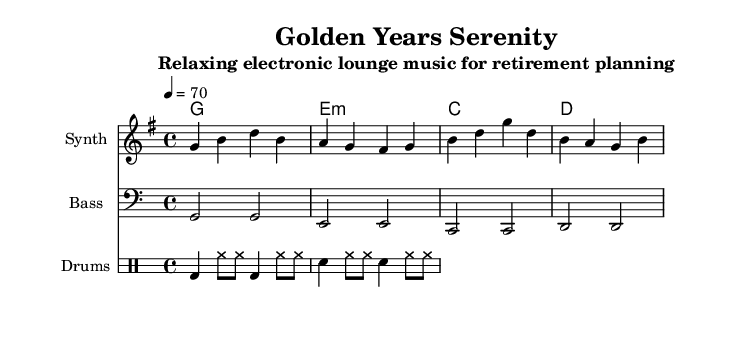What is the key signature of this music? The key signature is indicated at the beginning of the staff. This particular music is in the key of G major, which has one sharp (F#).
Answer: G major What is the time signature of this music? The time signature appears at the beginning of the score, showing that each measure consists of four beats, indicated by the number 4 over the number 4.
Answer: 4/4 What is the tempo marking for this piece? The tempo is specified at the beginning and is indicated with the notation "4 = 70," meaning there are 70 beats per minute.
Answer: 70 How many measures are in the melody section? By counting the distinct sets of notes, we find that there are a total of four measures in the melody section, as divided by the bar lines.
Answer: 4 Which instrument plays the bass part? The score shows a specific staff labeled "Bass," indicating that the bass part is performed by a bass instrument, typically a synthesizer in electronic music.
Answer: Bass What types of chords are used in the harmony section? The harmony section contains the chords G major, E minor, C major, and D major, which can be identified by their names written under the staff.
Answer: G, E minor, C, D What is the style of the drum pattern in this piece? By analyzing the drum staff, we observe a consistent pattern of bass drums and hi-hats, which is characteristic of electronic lounge music, providing a relaxed groove.
Answer: Electronic lounge 